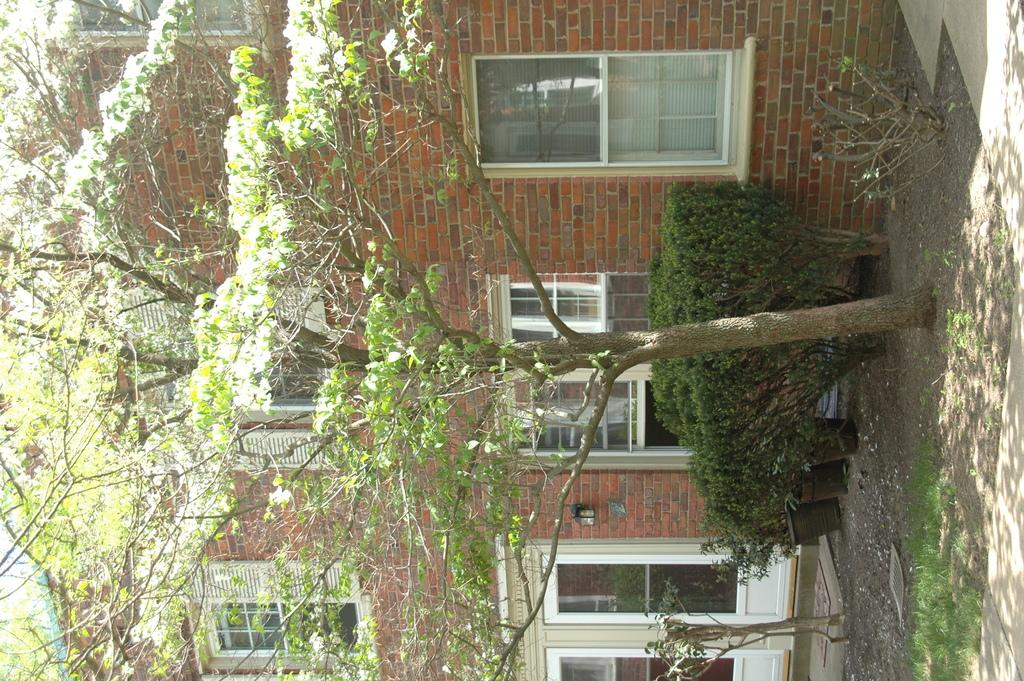What is located in the foreground of the image? There is a tree and plants in pots in the foreground of the image. What can be seen in the background of the image? There is a building in the background of the image. What features does the building have? The building has windows and glass doors. Are there any additional objects or features in the background of the image? Yes, there is a lamp on the wall in the background of the image. What type of education does the daughter receive in the image? There is no daughter present in the image, and therefore no information about her education can be provided. What advice does the coach give to the players in the image? There is no coach or players present in the image, so no advice can be given. 